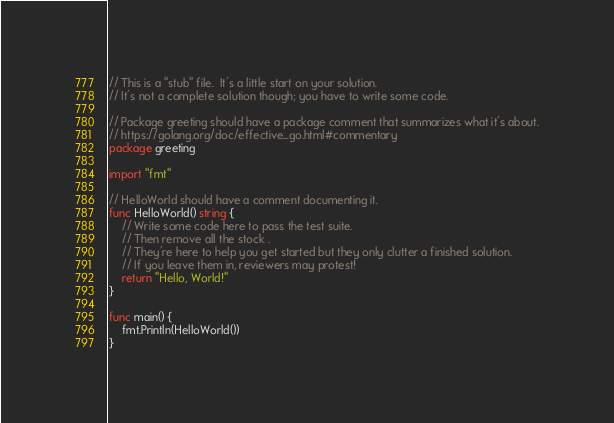Convert code to text. <code><loc_0><loc_0><loc_500><loc_500><_Go_>// This is a "stub" file.  It's a little start on your solution.
// It's not a complete solution though; you have to write some code.

// Package greeting should have a package comment that summarizes what it's about.
// https://golang.org/doc/effective_go.html#commentary
package greeting

import "fmt"

// HelloWorld should have a comment documenting it.
func HelloWorld() string {
	// Write some code here to pass the test suite.
	// Then remove all the stock .
	// They're here to help you get started but they only clutter a finished solution.
	// If you leave them in, reviewers may protest!
	return "Hello, World!"
}

func main() {
	fmt.Println(HelloWorld())
}
</code> 